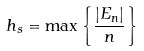<formula> <loc_0><loc_0><loc_500><loc_500>h _ { s } = \max \left \{ \frac { \left | E _ { n } \right | } { n } \right \}</formula> 